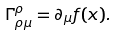<formula> <loc_0><loc_0><loc_500><loc_500>\Gamma ^ { \rho } _ { \rho \mu } = \partial _ { \mu } f ( x ) .</formula> 